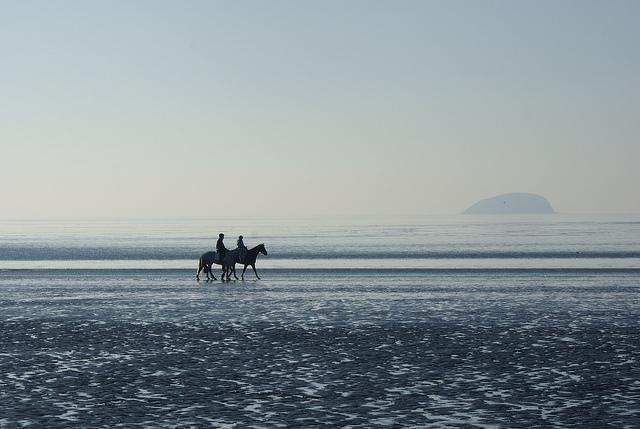How many train cars can be seen?
Give a very brief answer. 0. 